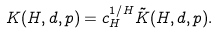Convert formula to latex. <formula><loc_0><loc_0><loc_500><loc_500>K ( H , d , p ) = c _ { H } ^ { 1 / H } \tilde { K } ( H , d , p ) .</formula> 